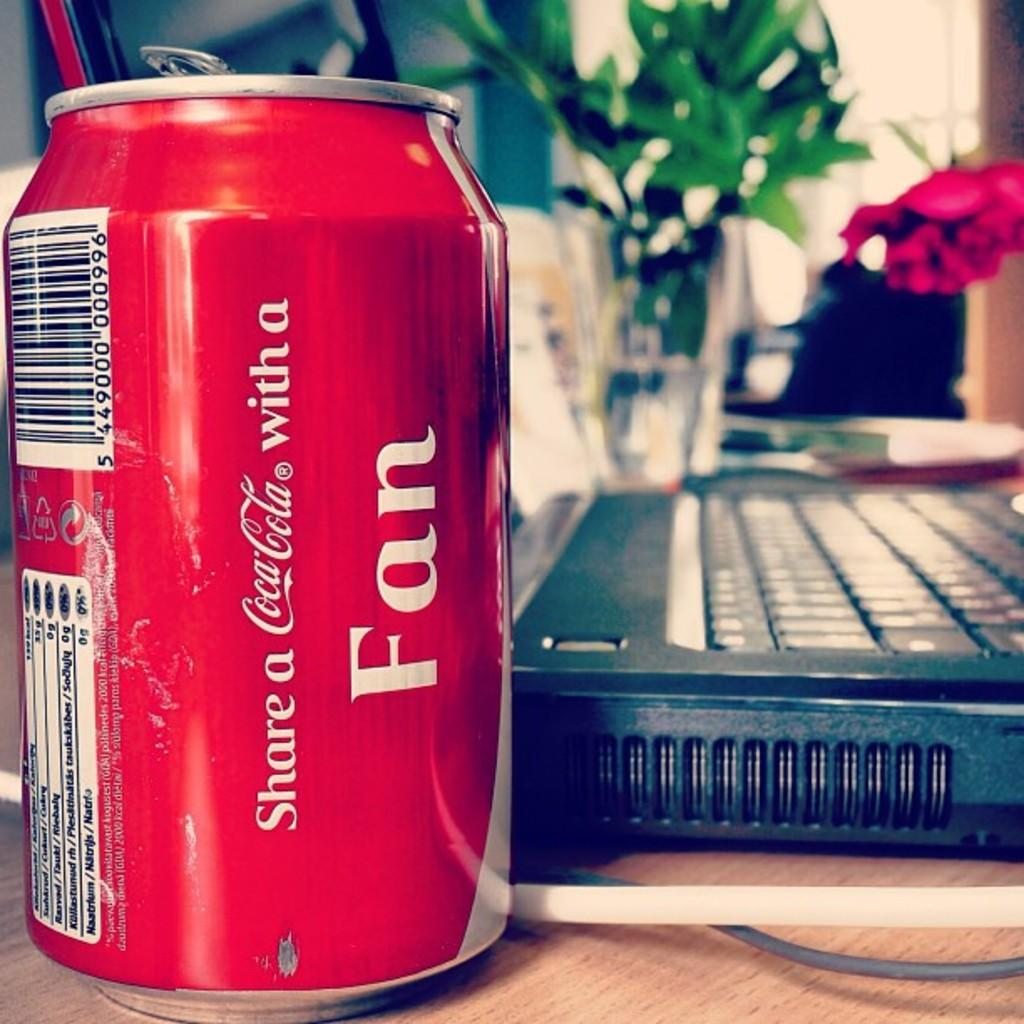<image>
Summarize the visual content of the image. Red soda can which says the word FAN on it. 